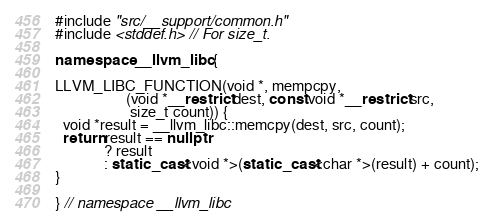Convert code to text. <code><loc_0><loc_0><loc_500><loc_500><_C++_>#include "src/__support/common.h"
#include <stddef.h> // For size_t.

namespace __llvm_libc {

LLVM_LIBC_FUNCTION(void *, mempcpy,
                   (void *__restrict dest, const void *__restrict src,
                    size_t count)) {
  void *result = __llvm_libc::memcpy(dest, src, count);
  return result == nullptr
             ? result
             : static_cast<void *>(static_cast<char *>(result) + count);
}

} // namespace __llvm_libc
</code> 